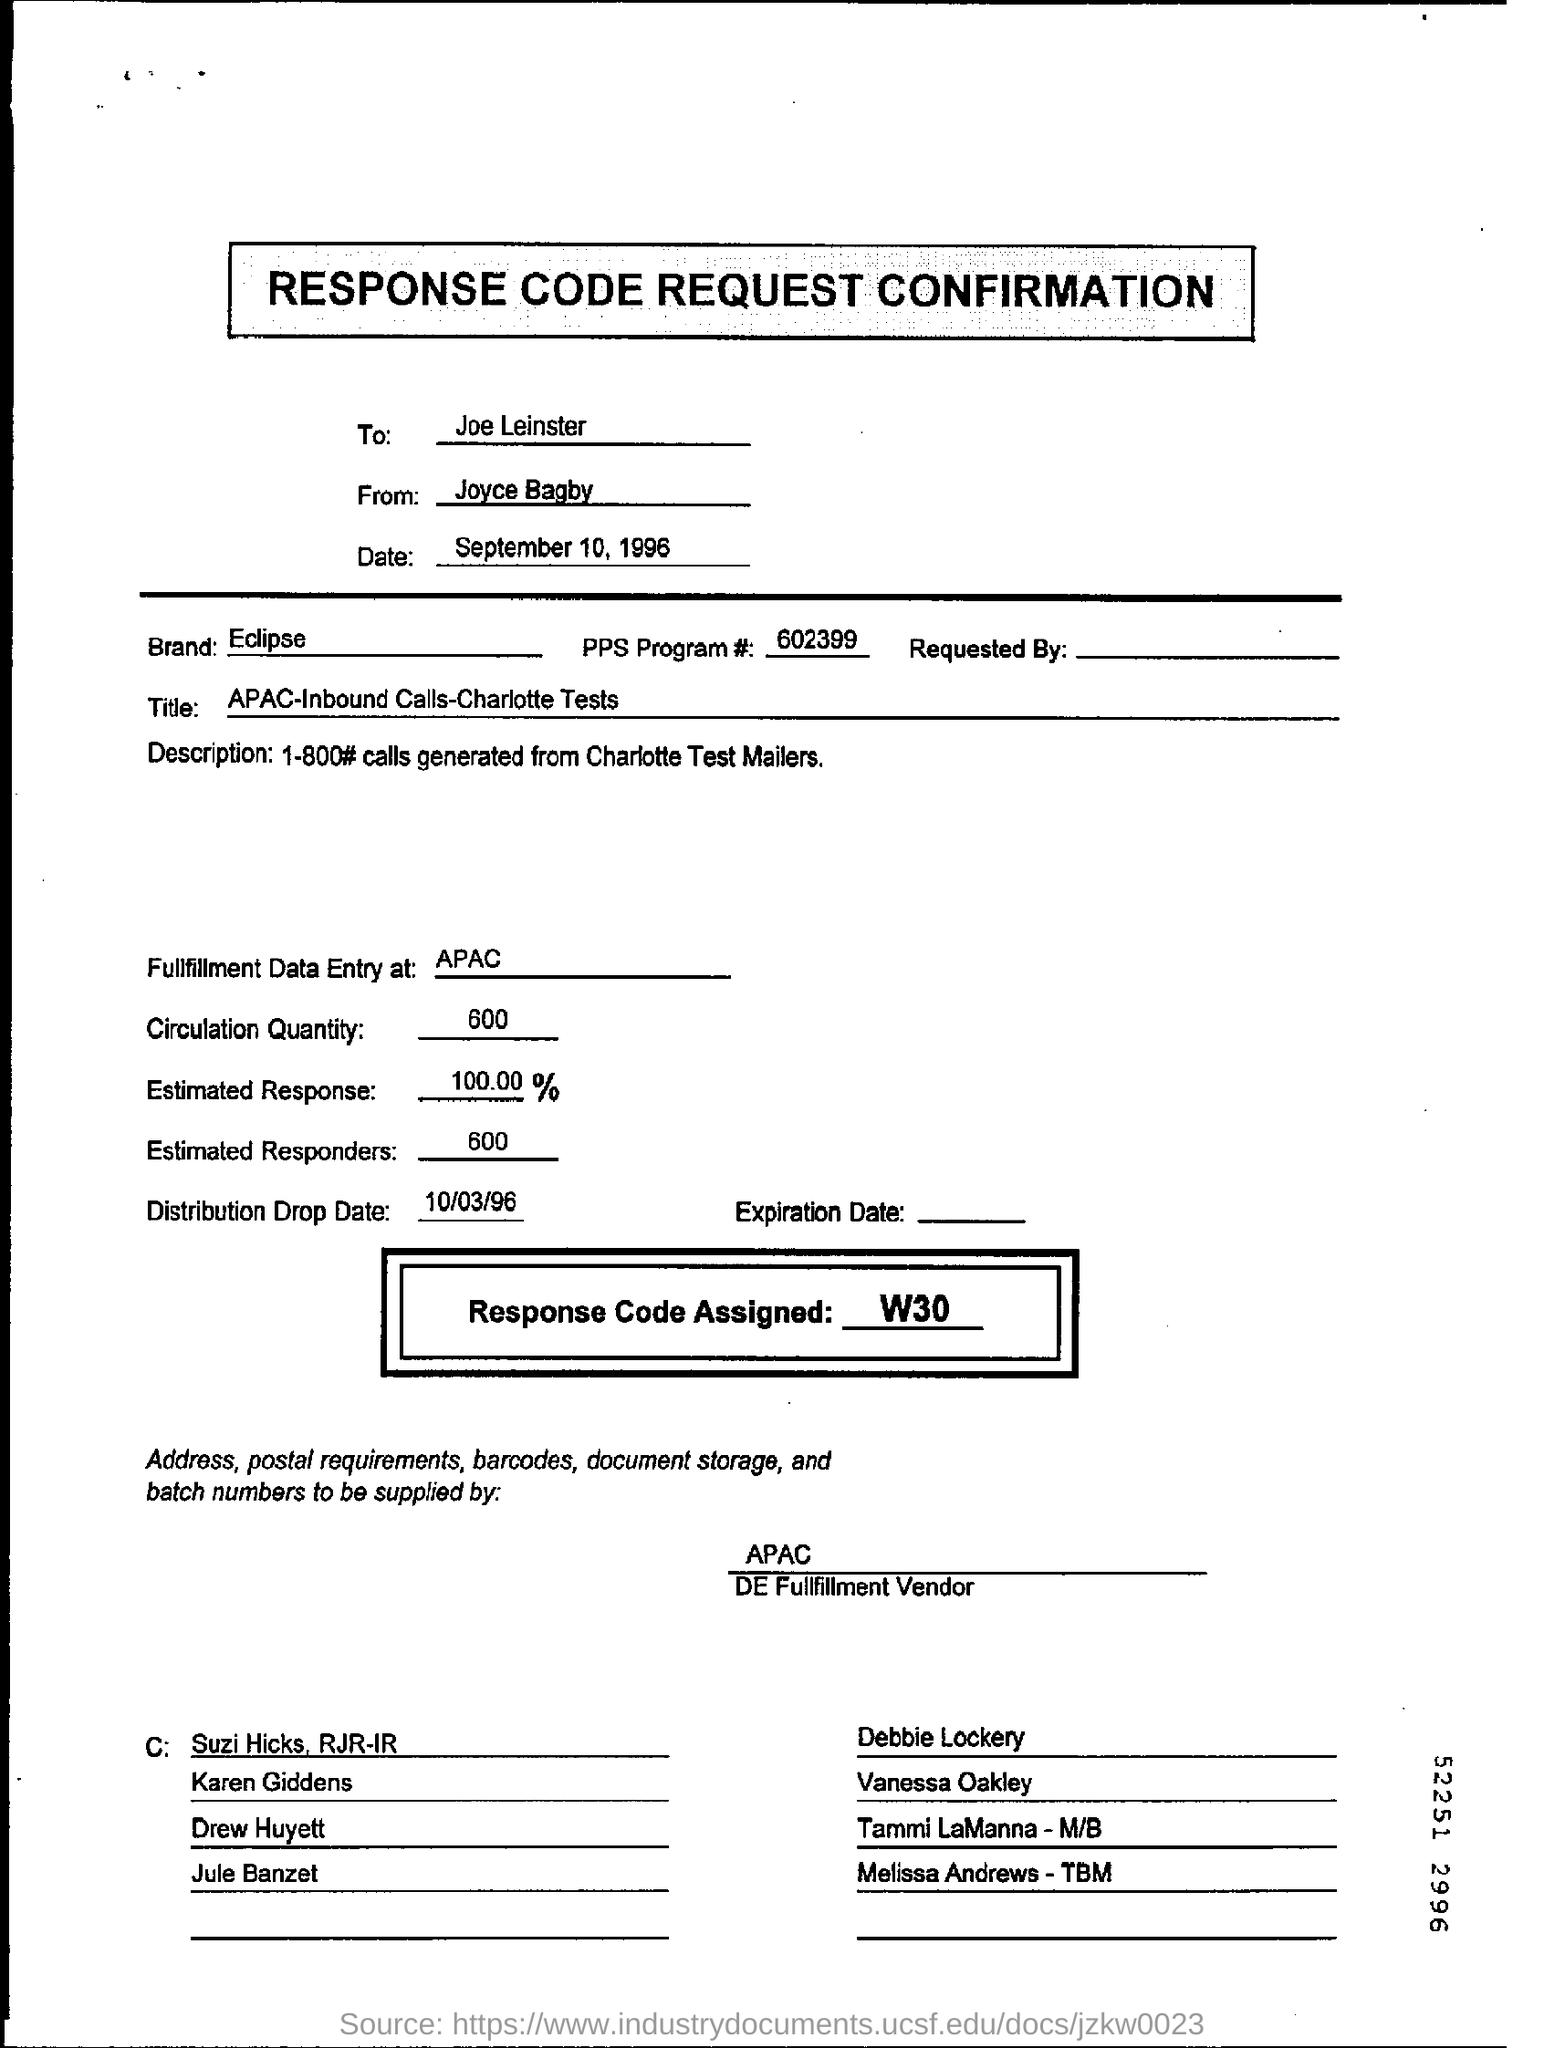List a handful of essential elements in this visual. The circulation quantity, as stated in the document, is 600. According to the document, there are an estimated 600 responders. The distribution drop date mentioned in the document is October 3, 1996. The PPS Program # is 602399. Joyce Bagby is the sender of the Response Code Request Confirmation. 